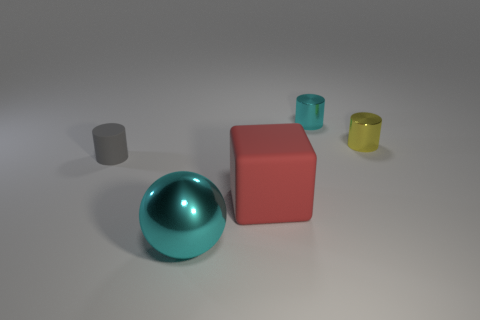Is there a cylinder that has the same color as the metallic sphere?
Make the answer very short. Yes. What size is the cylinder that is the same color as the shiny sphere?
Offer a terse response. Small. Is the cyan object in front of the small matte object made of the same material as the small thing that is on the right side of the small cyan metallic object?
Your answer should be compact. Yes. Are there any other things that have the same shape as the small yellow shiny thing?
Make the answer very short. Yes. Does the big cyan object have the same material as the small object that is to the right of the small cyan cylinder?
Offer a very short reply. Yes. What is the color of the rubber thing in front of the cylinder that is left of the large object that is behind the cyan sphere?
Make the answer very short. Red. What shape is the cyan shiny object that is the same size as the cube?
Your answer should be compact. Sphere. Are there any other things that are the same size as the red cube?
Ensure brevity in your answer.  Yes. Do the cyan shiny thing that is on the right side of the large cyan metallic object and the thing that is left of the big cyan metal thing have the same size?
Your response must be concise. Yes. There is a cyan metal thing in front of the tiny gray rubber cylinder; what size is it?
Ensure brevity in your answer.  Large. 